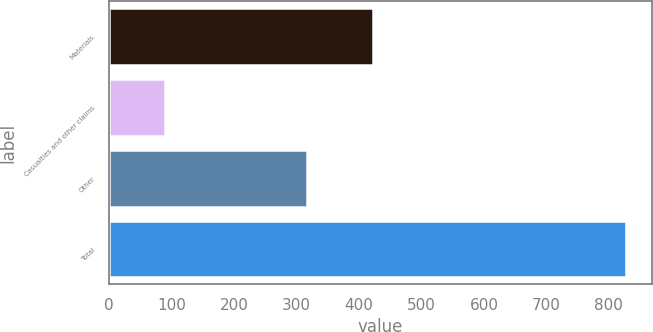Convert chart. <chart><loc_0><loc_0><loc_500><loc_500><bar_chart><fcel>Materials<fcel>Casualties and other claims<fcel>Other<fcel>Total<nl><fcel>422<fcel>90<fcel>316<fcel>828<nl></chart> 